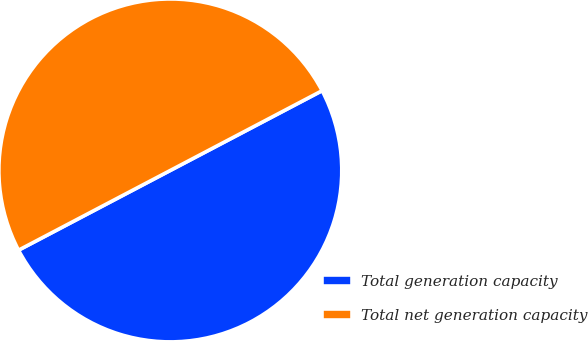Convert chart to OTSL. <chart><loc_0><loc_0><loc_500><loc_500><pie_chart><fcel>Total generation capacity<fcel>Total net generation capacity<nl><fcel>50.0%<fcel>50.0%<nl></chart> 